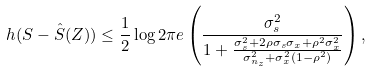<formula> <loc_0><loc_0><loc_500><loc_500>h ( S - \hat { S } ( Z ) ) \leq \frac { 1 } { 2 } \log 2 \pi e \left ( \frac { \sigma _ { s } ^ { 2 } } { 1 + \frac { \sigma _ { s } ^ { 2 } + 2 \rho \sigma _ { s } \sigma _ { x } + \rho ^ { 2 } \sigma _ { x } ^ { 2 } } { \sigma _ { n _ { z } } ^ { 2 } + \sigma _ { x } ^ { 2 } ( 1 - \rho ^ { 2 } ) } } \right ) ,</formula> 